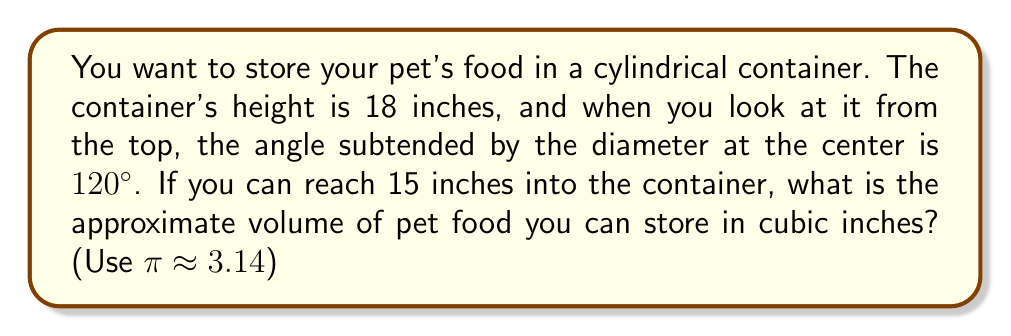Can you answer this question? Let's approach this step-by-step:

1) First, we need to find the radius of the container. We can use the fact that the angle subtended by the diameter is 120°.

2) In a circle, the angle subtended by an arc at the center is twice the angle subtended at any point on the circle. So, if we consider a right-angled triangle formed by the radius:

   $$\tan(\frac{120°}{4}) = \frac{r}{15}$$

   Where r is the radius and 15 is how far we can reach into the container.

3) Solving for r:
   $$r = 15 \tan(30°) = 15 * \frac{\sqrt{3}}{3} \approx 8.66 \text{ inches}$$

4) Now that we have the radius, we can calculate the volume using the formula for a cylinder:
   $$V = \pi r^2 h$$

   Where h is the height of the container (18 inches).

5) Substituting our values:
   $$V \approx 3.14 * 8.66^2 * 18$$

6) Calculating:
   $$V \approx 3.14 * 75 * 18 \approx 4,239 \text{ cubic inches}$$
Answer: Approximately 4,239 cubic inches 